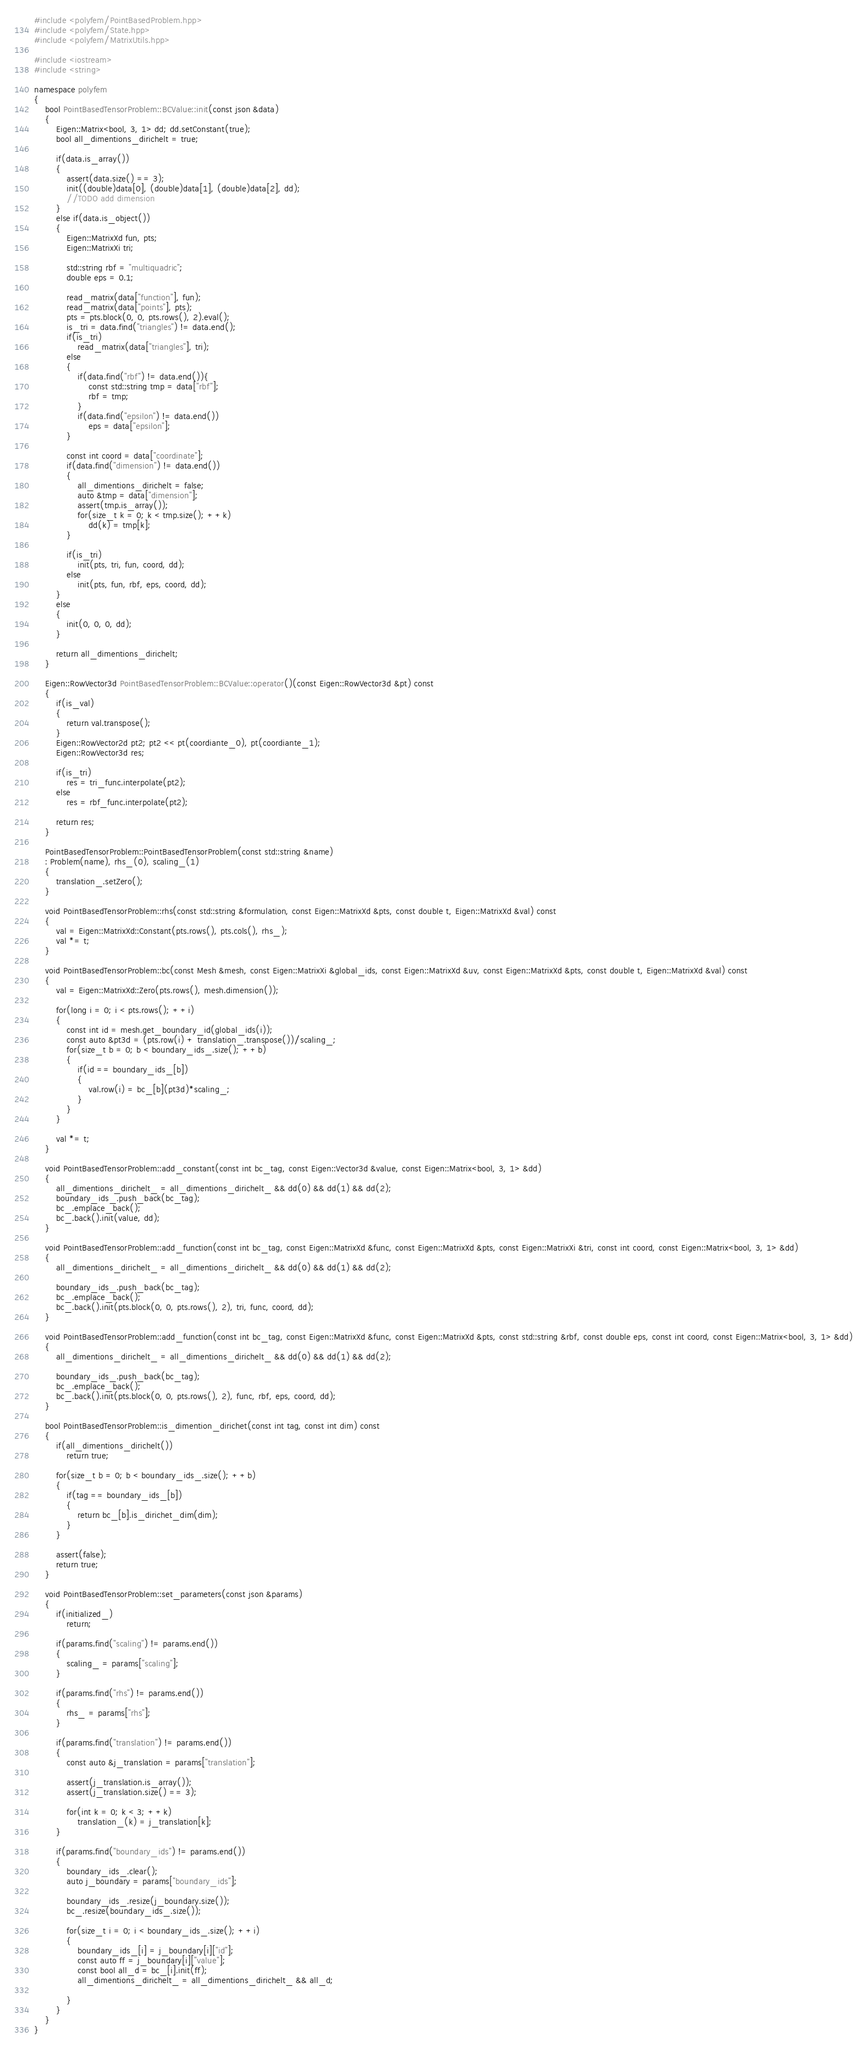<code> <loc_0><loc_0><loc_500><loc_500><_C++_>#include <polyfem/PointBasedProblem.hpp>
#include <polyfem/State.hpp>
#include <polyfem/MatrixUtils.hpp>

#include <iostream>
#include <string>

namespace polyfem
{
	bool PointBasedTensorProblem::BCValue::init(const json &data)
	{
		Eigen::Matrix<bool, 3, 1> dd; dd.setConstant(true);
		bool all_dimentions_dirichelt = true;

		if(data.is_array())
		{
			assert(data.size() == 3);
			init((double)data[0], (double)data[1], (double)data[2], dd);
			//TODO add dimension
		}
		else if(data.is_object())
		{
			Eigen::MatrixXd fun, pts;
			Eigen::MatrixXi tri;

			std::string rbf = "multiquadric";
			double eps = 0.1;

			read_matrix(data["function"], fun);
			read_matrix(data["points"], pts);
			pts = pts.block(0, 0, pts.rows(), 2).eval();
			is_tri = data.find("triangles") != data.end();
			if(is_tri)
				read_matrix(data["triangles"], tri);
			else
			{
				if(data.find("rbf") != data.end()){
					const std::string tmp = data["rbf"];
					rbf = tmp;
				}
				if(data.find("epsilon") != data.end())
					eps = data["epsilon"];
			}

			const int coord = data["coordinate"];
			if(data.find("dimension") != data.end())
			{
				all_dimentions_dirichelt = false;
				auto &tmp = data["dimension"];
				assert(tmp.is_array());
				for(size_t k = 0; k < tmp.size(); ++k)
					dd(k) = tmp[k];
			}

			if(is_tri)
				init(pts, tri, fun, coord, dd);
			else
				init(pts, fun, rbf, eps, coord, dd);
		}
		else
		{
			init(0, 0, 0, dd);
		}

		return all_dimentions_dirichelt;
	}

	Eigen::RowVector3d PointBasedTensorProblem::BCValue::operator()(const Eigen::RowVector3d &pt) const
	{
		if(is_val)
		{
			return val.transpose();
		}
		Eigen::RowVector2d pt2; pt2 << pt(coordiante_0), pt(coordiante_1);
		Eigen::RowVector3d res;

		if(is_tri)
			res = tri_func.interpolate(pt2);
		else
			res = rbf_func.interpolate(pt2);

		return res;
	}

	PointBasedTensorProblem::PointBasedTensorProblem(const std::string &name)
	: Problem(name), rhs_(0), scaling_(1)
	{
		translation_.setZero();
	}

	void PointBasedTensorProblem::rhs(const std::string &formulation, const Eigen::MatrixXd &pts, const double t, Eigen::MatrixXd &val) const
	{
		val = Eigen::MatrixXd::Constant(pts.rows(), pts.cols(), rhs_);
		val *= t;
	}

	void PointBasedTensorProblem::bc(const Mesh &mesh, const Eigen::MatrixXi &global_ids, const Eigen::MatrixXd &uv, const Eigen::MatrixXd &pts, const double t, Eigen::MatrixXd &val) const
	{
		val = Eigen::MatrixXd::Zero(pts.rows(), mesh.dimension());

		for(long i = 0; i < pts.rows(); ++i)
		{
			const int id = mesh.get_boundary_id(global_ids(i));
			const auto &pt3d = (pts.row(i) + translation_.transpose())/scaling_;
			for(size_t b = 0; b < boundary_ids_.size(); ++b)
			{
				if(id == boundary_ids_[b])
				{
					val.row(i) = bc_[b](pt3d)*scaling_;
				}
			}
		}

		val *= t;
	}

	void PointBasedTensorProblem::add_constant(const int bc_tag, const Eigen::Vector3d &value, const Eigen::Matrix<bool, 3, 1> &dd)
	{
		all_dimentions_dirichelt_ = all_dimentions_dirichelt_ && dd(0) && dd(1) && dd(2);
		boundary_ids_.push_back(bc_tag);
		bc_.emplace_back();
		bc_.back().init(value, dd);
	}

	void PointBasedTensorProblem::add_function(const int bc_tag, const Eigen::MatrixXd &func, const Eigen::MatrixXd &pts, const Eigen::MatrixXi &tri, const int coord, const Eigen::Matrix<bool, 3, 1> &dd)
	{
		all_dimentions_dirichelt_ = all_dimentions_dirichelt_ && dd(0) && dd(1) && dd(2);

		boundary_ids_.push_back(bc_tag);
		bc_.emplace_back();
		bc_.back().init(pts.block(0, 0, pts.rows(), 2), tri, func, coord, dd);
	}

	void PointBasedTensorProblem::add_function(const int bc_tag, const Eigen::MatrixXd &func, const Eigen::MatrixXd &pts, const std::string &rbf, const double eps, const int coord, const Eigen::Matrix<bool, 3, 1> &dd)
	{
		all_dimentions_dirichelt_ = all_dimentions_dirichelt_ && dd(0) && dd(1) && dd(2);

		boundary_ids_.push_back(bc_tag);
		bc_.emplace_back();
		bc_.back().init(pts.block(0, 0, pts.rows(), 2), func, rbf, eps, coord, dd);
	}

	bool PointBasedTensorProblem::is_dimention_dirichet(const int tag, const int dim) const
	{
		if(all_dimentions_dirichelt())
			return true;

		for(size_t b = 0; b < boundary_ids_.size(); ++b)
		{
			if(tag == boundary_ids_[b])
			{
				return bc_[b].is_dirichet_dim(dim);
			}
		}

		assert(false);
		return true;
	}

	void PointBasedTensorProblem::set_parameters(const json &params)
	{
		if(initialized_)
			return;

		if(params.find("scaling") != params.end())
		{
			scaling_ = params["scaling"];
		}

		if(params.find("rhs") != params.end())
		{
			rhs_ = params["rhs"];
		}

		if(params.find("translation") != params.end())
		{
			const auto &j_translation = params["translation"];

			assert(j_translation.is_array());
			assert(j_translation.size() == 3);

			for(int k = 0; k < 3; ++k)
				translation_(k) = j_translation[k];
		}

		if(params.find("boundary_ids") != params.end())
		{
			boundary_ids_.clear();
			auto j_boundary = params["boundary_ids"];

			boundary_ids_.resize(j_boundary.size());
			bc_.resize(boundary_ids_.size());

			for(size_t i = 0; i < boundary_ids_.size(); ++i)
			{
				boundary_ids_[i] = j_boundary[i]["id"];
				const auto ff = j_boundary[i]["value"];
				const bool all_d = bc_[i].init(ff);
				all_dimentions_dirichelt_ = all_dimentions_dirichelt_ && all_d;

			}
		}
	}
}
</code> 